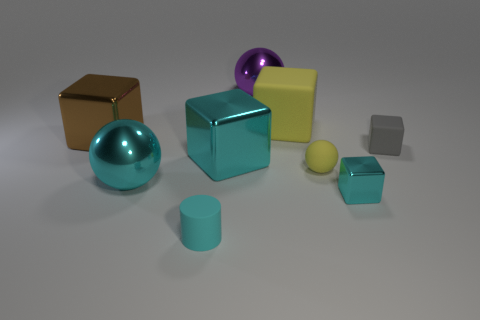Subtract all big cyan metallic cubes. How many cubes are left? 4 Subtract all cyan cubes. How many cubes are left? 3 Subtract 2 balls. How many balls are left? 1 Subtract all cylinders. How many objects are left? 8 Subtract all red spheres. Subtract all red cubes. How many spheres are left? 3 Subtract all yellow balls. How many yellow blocks are left? 1 Add 1 large brown shiny things. How many objects exist? 10 Subtract all brown metallic cubes. Subtract all cyan blocks. How many objects are left? 6 Add 5 large cyan objects. How many large cyan objects are left? 7 Add 6 small things. How many small things exist? 10 